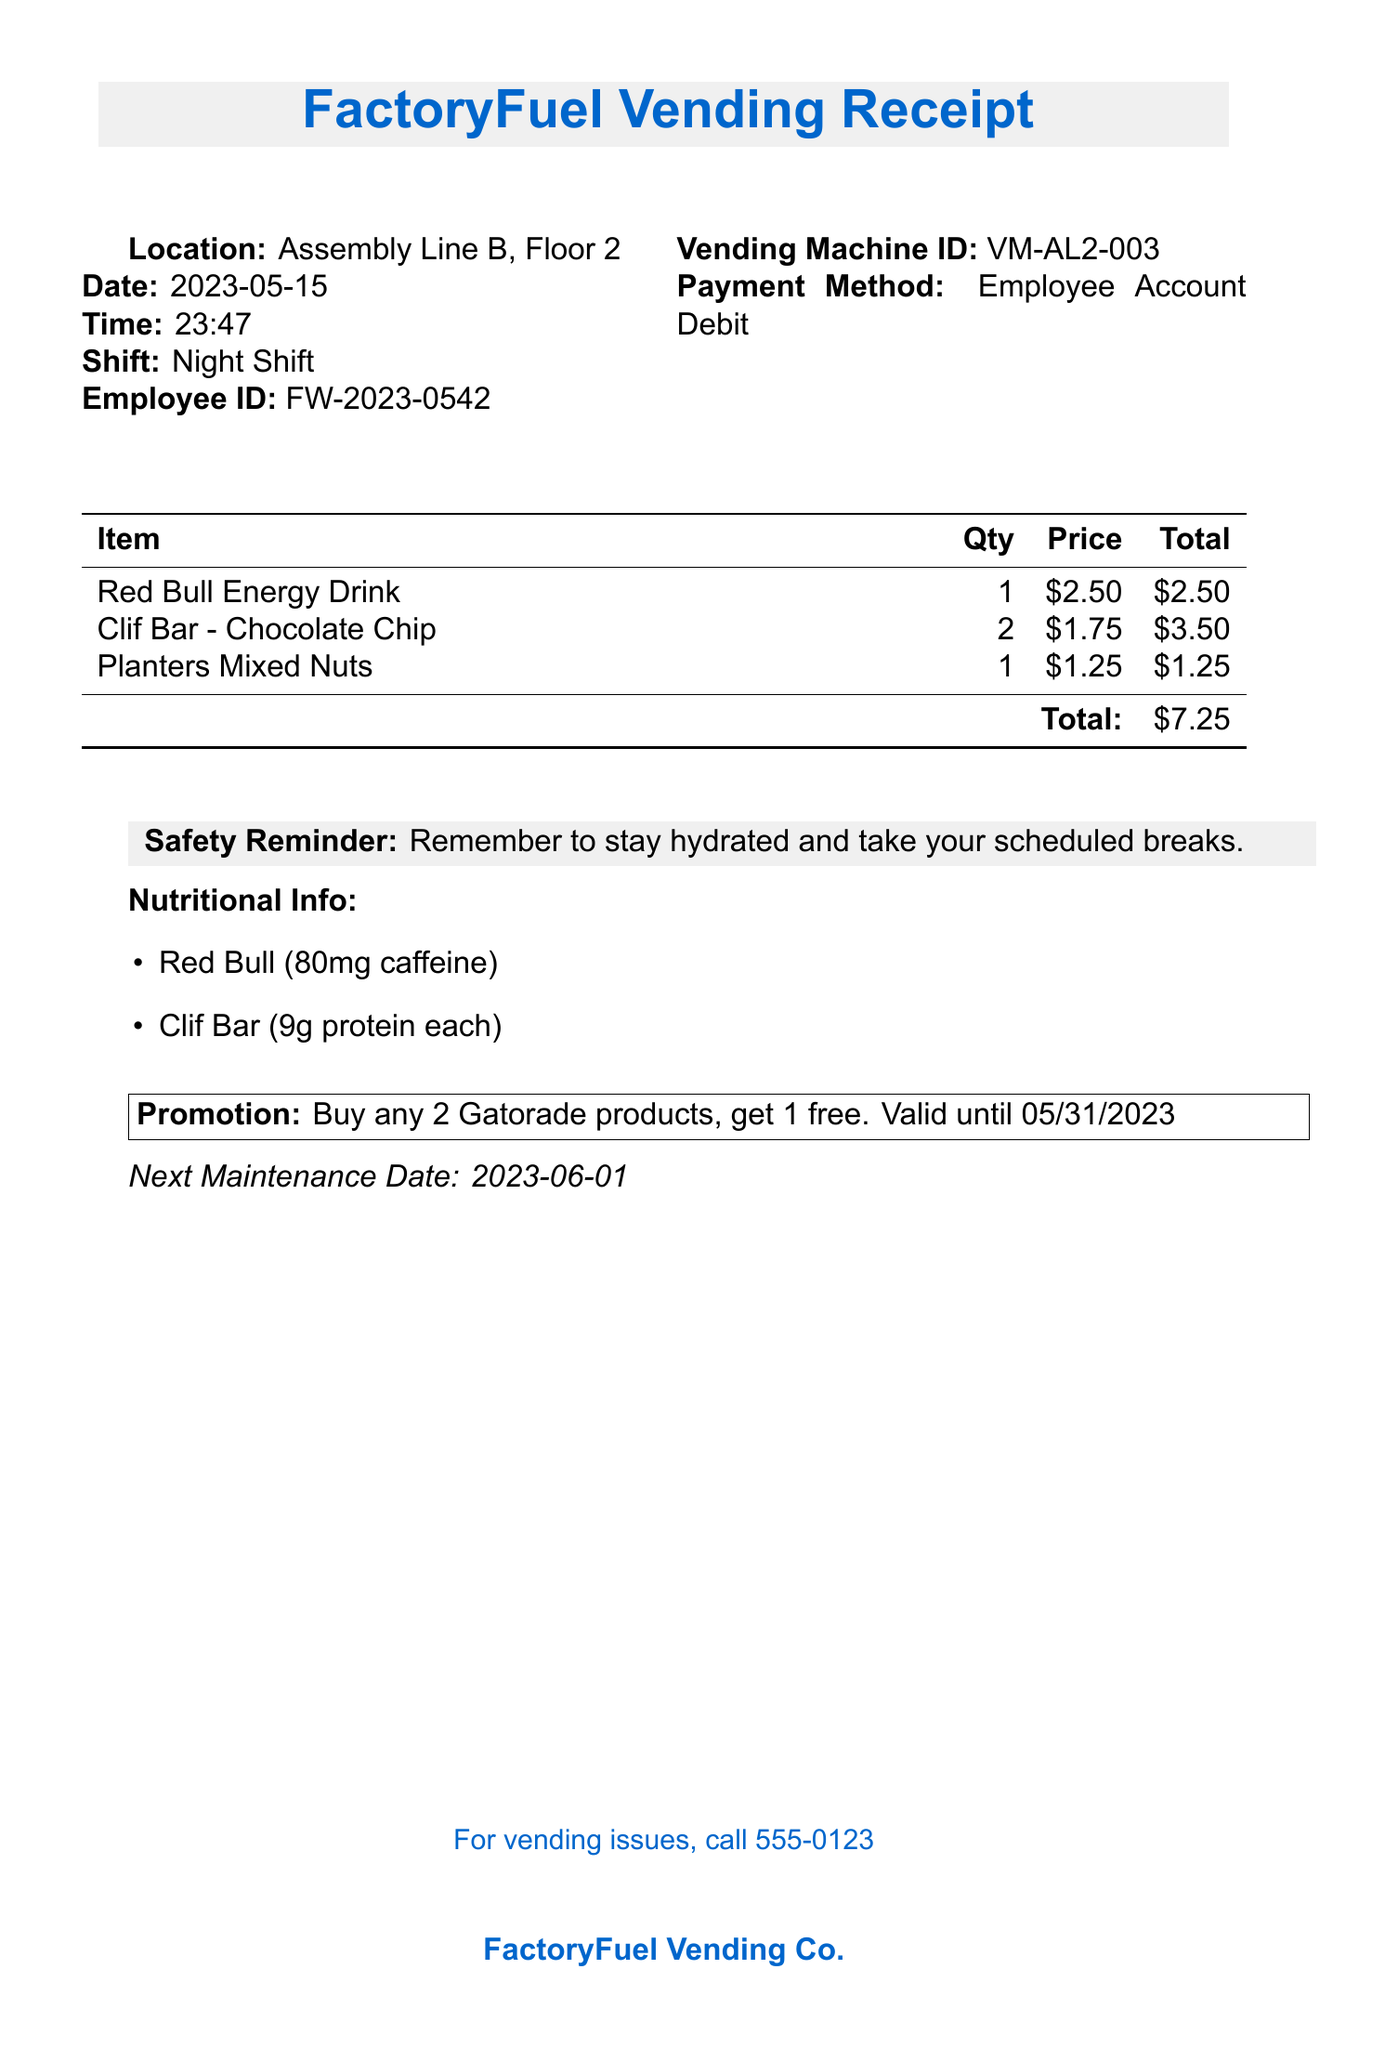What is the vendor name? The vendor name is listed at the top of the receipt.
Answer: FactoryFuel Vending Co What is the total amount spent? The total amount is shown at the end of the itemized list.
Answer: $7.25 What items were purchased? The items are listed in the table with descriptions.
Answer: Red Bull Energy Drink, Clif Bar - Chocolate Chip, Planters Mixed Nuts What is the date of the transaction? The date is shown prominently near the top of the receipt.
Answer: 2023-05-15 How many Clif Bars were bought? The quantity is specified in the itemized list next to the Clif Bar entry.
Answer: 2 What is the safety reminder? The safety reminder is highlighted at the bottom of the document.
Answer: Remember to stay hydrated and take your scheduled breaks What is the employee ID? The employee ID is listed under the employee information section.
Answer: FW-2023-0542 When is the next maintenance date for the vending machine? The next maintenance date is specified in the relevant section of the receipt.
Answer: 2023-06-01 What promotion is mentioned on the receipt? The promotion is detailed in a highlighted box on the receipt.
Answer: Buy any 2 Gatorade products, get 1 free. Valid until 05/31/2023 